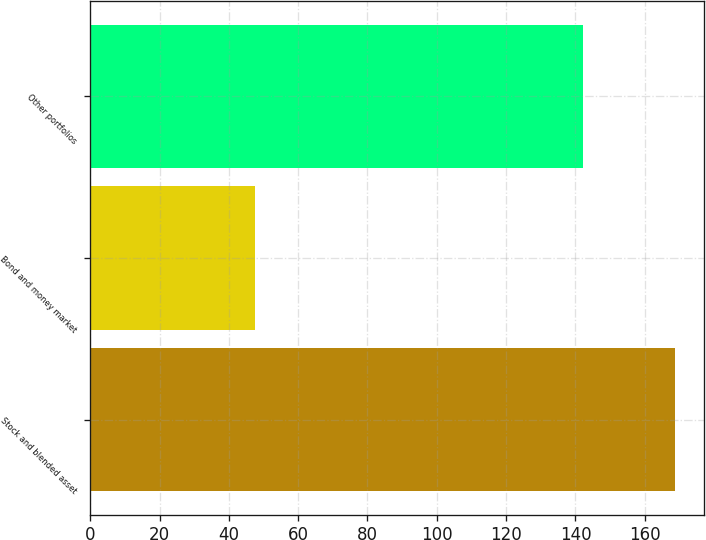<chart> <loc_0><loc_0><loc_500><loc_500><bar_chart><fcel>Stock and blended asset<fcel>Bond and money market<fcel>Other portfolios<nl><fcel>168.6<fcel>47.5<fcel>142.1<nl></chart> 